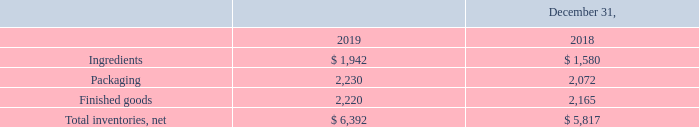Note 3 – Inventories, net
Inventories consisted of the following:
What is the value of ingredients in 2019? 1,942. What is the value of packaging in 2019? 2,230. What is the value of finished goods in 2019? 2,220. What is the percentage change in ingredients between 2018 and 2019?
Answer scale should be: percent. (1,942-1,580)/1,580
Answer: 22.91. What is the change in finished goods between 2018 and 2019? 2,220-2,165
Answer: 55. What is the average value of packaging for years 2018 and 2019? (2,230+2,072)/2
Answer: 2151. 